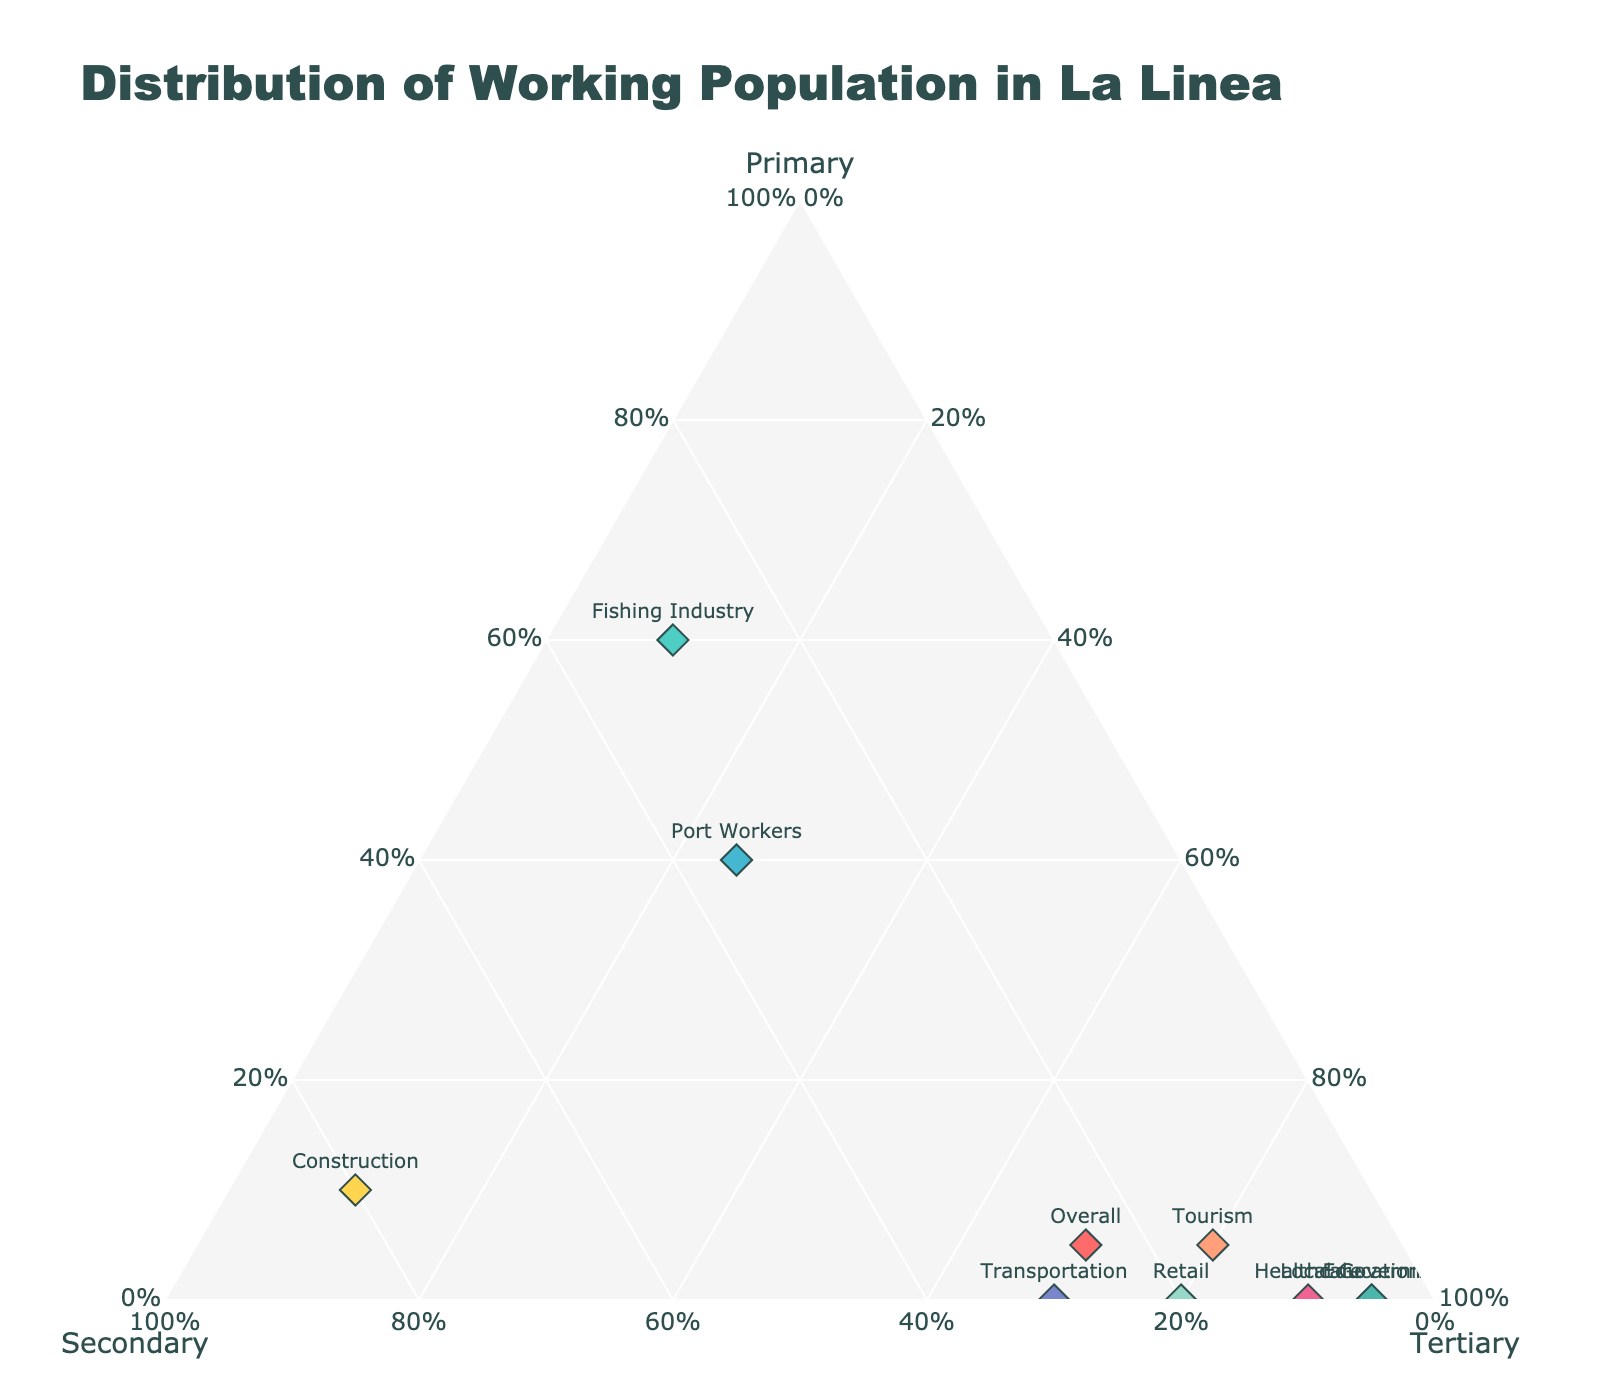What is the title of this figure? The title is located at the top center of the plot and it usually gives an overview of what the figure represents. The title is 'Distribution of Working Population in La Linea'.
Answer: Distribution of Working Population in La Linea Which sector has the highest percentage in the Primary sector? The Primary sector percentages are given on one of the axes and the highest percentage is marked on the plot. The Fishing Industry has 60%.
Answer: Fishing Industry How many sectors have more than 70% in the Tertiary sector? By examining the Tertiary axis and looking at the points plotted, we can see that Tourism, Retail, Healthcare, Education, and Local Government all have percentages above 70%. There are 5 sectors.
Answer: 5 Compare the Port Workers and Construction sectors: which one has a larger percentage in the Secondary sector? By observing the percentages for the Secondary sector, Port Workers have 35% while Construction has 80%. Construction has a larger percentage.
Answer: Construction What is the percentage of Transportation in the Tertiary sector? Hovering or checking the labels for the data point representing Transportation in the Tertiary axis shows a 70% value.
Answer: 70% If you combine the Tertiary percentages of Retail and Education, what is the total? Retail has 80% and Education has 95% in the Tertiary sector. Sum of these is 80 + 95 = 175%.
Answer: 175% Which sector is represented by the point closest to the apex for the Tertiary sector? The apex closest to the 100% on the Tertiary axis identifies the point with the highest value. Education represents the point closest to this apex with 95% in the Tertiary sector.
Answer: Education Do any sectors have an equal percentage in both the Primary and Tertiary sectors? Checking the plot for points where Primary and Tertiary values are equal, we see that none of them have equal percentages in these two sectors.
Answer: No What is the average percentage of the Primary sector across all sectors? Sum the Primary sector percentages for all sectors: 5 + 60 + 40 + 5 + 0 + 0 + 0 + 10 + 0 + 0 = 120%. Divide by the number of sectors which is 10. The average is 120/10 = 12%.
Answer: 12% Which sector has the lowest percentage in the Secondary sector? The Secondary values can be checked to identify the smallest value. Education and Local Government both have 5%, which is the lowest.
Answer: Education, Local Government 